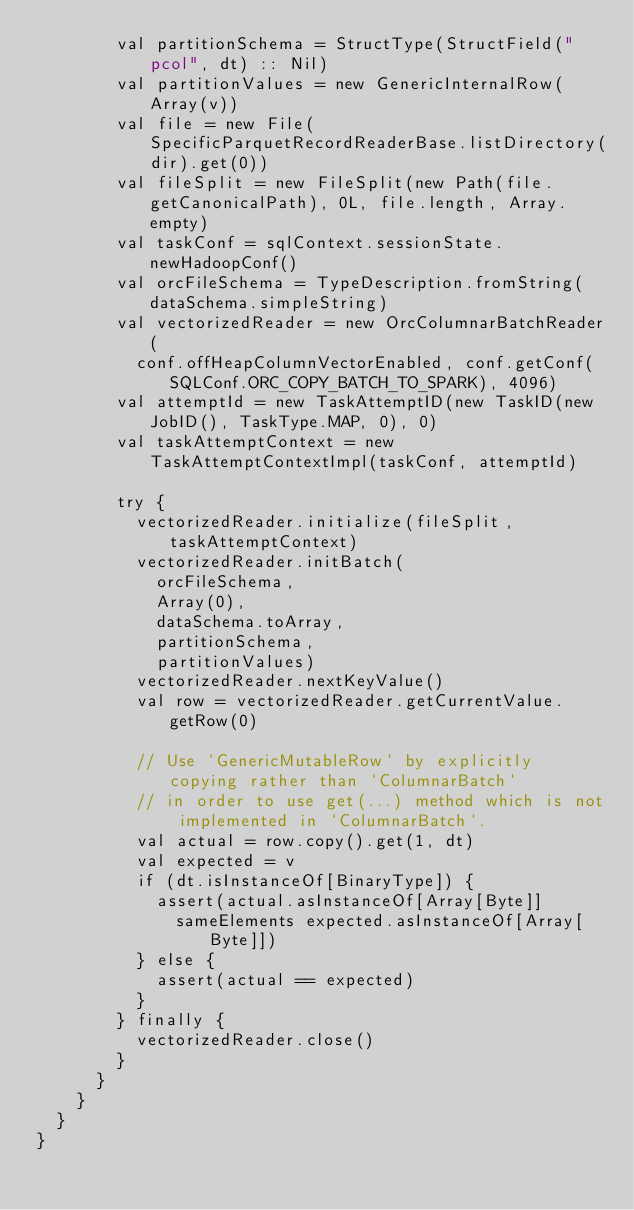Convert code to text. <code><loc_0><loc_0><loc_500><loc_500><_Scala_>        val partitionSchema = StructType(StructField("pcol", dt) :: Nil)
        val partitionValues = new GenericInternalRow(Array(v))
        val file = new File(SpecificParquetRecordReaderBase.listDirectory(dir).get(0))
        val fileSplit = new FileSplit(new Path(file.getCanonicalPath), 0L, file.length, Array.empty)
        val taskConf = sqlContext.sessionState.newHadoopConf()
        val orcFileSchema = TypeDescription.fromString(dataSchema.simpleString)
        val vectorizedReader = new OrcColumnarBatchReader(
          conf.offHeapColumnVectorEnabled, conf.getConf(SQLConf.ORC_COPY_BATCH_TO_SPARK), 4096)
        val attemptId = new TaskAttemptID(new TaskID(new JobID(), TaskType.MAP, 0), 0)
        val taskAttemptContext = new TaskAttemptContextImpl(taskConf, attemptId)

        try {
          vectorizedReader.initialize(fileSplit, taskAttemptContext)
          vectorizedReader.initBatch(
            orcFileSchema,
            Array(0),
            dataSchema.toArray,
            partitionSchema,
            partitionValues)
          vectorizedReader.nextKeyValue()
          val row = vectorizedReader.getCurrentValue.getRow(0)

          // Use `GenericMutableRow` by explicitly copying rather than `ColumnarBatch`
          // in order to use get(...) method which is not implemented in `ColumnarBatch`.
          val actual = row.copy().get(1, dt)
          val expected = v
          if (dt.isInstanceOf[BinaryType]) {
            assert(actual.asInstanceOf[Array[Byte]]
              sameElements expected.asInstanceOf[Array[Byte]])
          } else {
            assert(actual == expected)
          }
        } finally {
          vectorizedReader.close()
        }
      }
    }
  }
}
</code> 